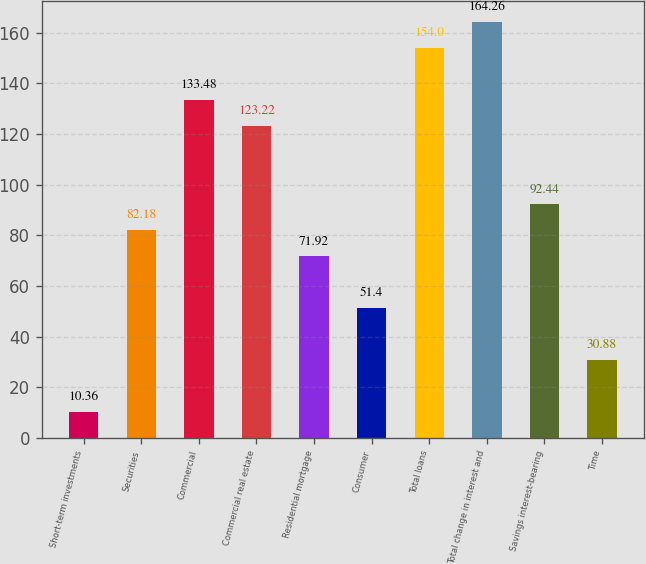Convert chart to OTSL. <chart><loc_0><loc_0><loc_500><loc_500><bar_chart><fcel>Short-term investments<fcel>Securities<fcel>Commercial<fcel>Commercial real estate<fcel>Residential mortgage<fcel>Consumer<fcel>Total loans<fcel>Total change in interest and<fcel>Savings interest-bearing<fcel>Time<nl><fcel>10.36<fcel>82.18<fcel>133.48<fcel>123.22<fcel>71.92<fcel>51.4<fcel>154<fcel>164.26<fcel>92.44<fcel>30.88<nl></chart> 